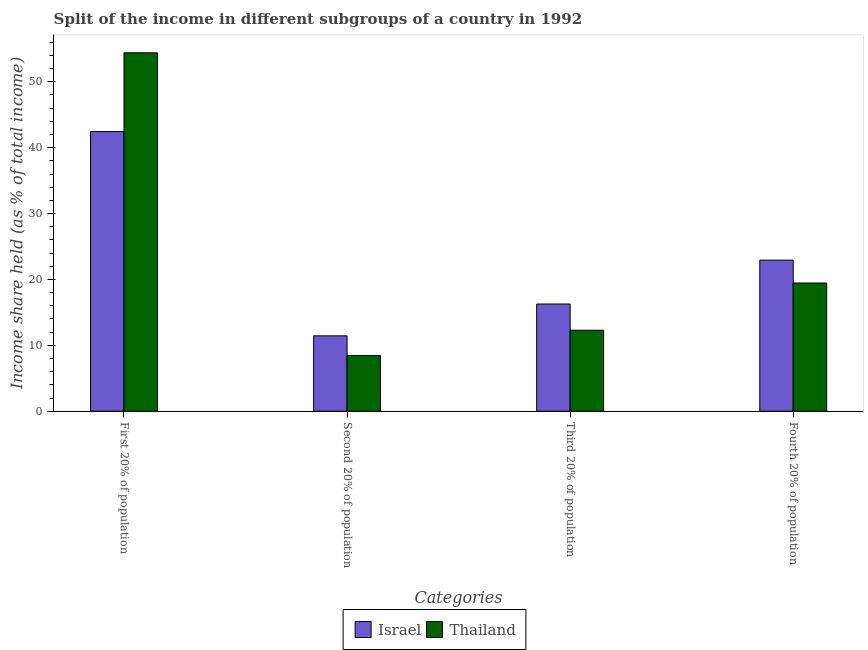How many different coloured bars are there?
Offer a terse response. 2. How many groups of bars are there?
Give a very brief answer. 4. Are the number of bars per tick equal to the number of legend labels?
Your answer should be very brief. Yes. How many bars are there on the 1st tick from the left?
Offer a very short reply. 2. How many bars are there on the 2nd tick from the right?
Your answer should be compact. 2. What is the label of the 3rd group of bars from the left?
Make the answer very short. Third 20% of population. What is the share of the income held by second 20% of the population in Thailand?
Offer a very short reply. 8.46. Across all countries, what is the maximum share of the income held by third 20% of the population?
Your answer should be very brief. 16.27. Across all countries, what is the minimum share of the income held by second 20% of the population?
Give a very brief answer. 8.46. In which country was the share of the income held by second 20% of the population maximum?
Make the answer very short. Israel. In which country was the share of the income held by third 20% of the population minimum?
Your answer should be compact. Thailand. What is the total share of the income held by third 20% of the population in the graph?
Provide a succinct answer. 28.56. What is the difference between the share of the income held by second 20% of the population in Israel and that in Thailand?
Make the answer very short. 2.98. What is the difference between the share of the income held by third 20% of the population in Thailand and the share of the income held by first 20% of the population in Israel?
Give a very brief answer. -30.15. What is the average share of the income held by second 20% of the population per country?
Ensure brevity in your answer.  9.95. What is the difference between the share of the income held by first 20% of the population and share of the income held by third 20% of the population in Thailand?
Keep it short and to the point. 42.11. In how many countries, is the share of the income held by fourth 20% of the population greater than 36 %?
Your answer should be very brief. 0. What is the ratio of the share of the income held by fourth 20% of the population in Thailand to that in Israel?
Provide a succinct answer. 0.85. What is the difference between the highest and the second highest share of the income held by second 20% of the population?
Offer a very short reply. 2.98. What is the difference between the highest and the lowest share of the income held by fourth 20% of the population?
Make the answer very short. 3.47. In how many countries, is the share of the income held by third 20% of the population greater than the average share of the income held by third 20% of the population taken over all countries?
Provide a short and direct response. 1. What does the 1st bar from the right in First 20% of population represents?
Ensure brevity in your answer.  Thailand. Is it the case that in every country, the sum of the share of the income held by first 20% of the population and share of the income held by second 20% of the population is greater than the share of the income held by third 20% of the population?
Make the answer very short. Yes. Are all the bars in the graph horizontal?
Provide a short and direct response. No. Are the values on the major ticks of Y-axis written in scientific E-notation?
Make the answer very short. No. Does the graph contain any zero values?
Offer a terse response. No. How many legend labels are there?
Keep it short and to the point. 2. How are the legend labels stacked?
Keep it short and to the point. Horizontal. What is the title of the graph?
Your response must be concise. Split of the income in different subgroups of a country in 1992. Does "Congo (Democratic)" appear as one of the legend labels in the graph?
Your response must be concise. No. What is the label or title of the X-axis?
Provide a short and direct response. Categories. What is the label or title of the Y-axis?
Provide a succinct answer. Income share held (as % of total income). What is the Income share held (as % of total income) in Israel in First 20% of population?
Your response must be concise. 42.44. What is the Income share held (as % of total income) in Thailand in First 20% of population?
Offer a terse response. 54.4. What is the Income share held (as % of total income) of Israel in Second 20% of population?
Ensure brevity in your answer.  11.44. What is the Income share held (as % of total income) of Thailand in Second 20% of population?
Your response must be concise. 8.46. What is the Income share held (as % of total income) in Israel in Third 20% of population?
Give a very brief answer. 16.27. What is the Income share held (as % of total income) in Thailand in Third 20% of population?
Offer a very short reply. 12.29. What is the Income share held (as % of total income) in Israel in Fourth 20% of population?
Give a very brief answer. 22.93. What is the Income share held (as % of total income) in Thailand in Fourth 20% of population?
Provide a succinct answer. 19.46. Across all Categories, what is the maximum Income share held (as % of total income) of Israel?
Your answer should be compact. 42.44. Across all Categories, what is the maximum Income share held (as % of total income) of Thailand?
Make the answer very short. 54.4. Across all Categories, what is the minimum Income share held (as % of total income) in Israel?
Provide a short and direct response. 11.44. Across all Categories, what is the minimum Income share held (as % of total income) of Thailand?
Your answer should be compact. 8.46. What is the total Income share held (as % of total income) of Israel in the graph?
Your answer should be compact. 93.08. What is the total Income share held (as % of total income) of Thailand in the graph?
Provide a short and direct response. 94.61. What is the difference between the Income share held (as % of total income) of Israel in First 20% of population and that in Second 20% of population?
Provide a short and direct response. 31. What is the difference between the Income share held (as % of total income) of Thailand in First 20% of population and that in Second 20% of population?
Offer a very short reply. 45.94. What is the difference between the Income share held (as % of total income) in Israel in First 20% of population and that in Third 20% of population?
Your answer should be very brief. 26.17. What is the difference between the Income share held (as % of total income) in Thailand in First 20% of population and that in Third 20% of population?
Your answer should be compact. 42.11. What is the difference between the Income share held (as % of total income) of Israel in First 20% of population and that in Fourth 20% of population?
Make the answer very short. 19.51. What is the difference between the Income share held (as % of total income) of Thailand in First 20% of population and that in Fourth 20% of population?
Make the answer very short. 34.94. What is the difference between the Income share held (as % of total income) in Israel in Second 20% of population and that in Third 20% of population?
Your response must be concise. -4.83. What is the difference between the Income share held (as % of total income) of Thailand in Second 20% of population and that in Third 20% of population?
Your answer should be very brief. -3.83. What is the difference between the Income share held (as % of total income) in Israel in Second 20% of population and that in Fourth 20% of population?
Your answer should be very brief. -11.49. What is the difference between the Income share held (as % of total income) in Israel in Third 20% of population and that in Fourth 20% of population?
Make the answer very short. -6.66. What is the difference between the Income share held (as % of total income) of Thailand in Third 20% of population and that in Fourth 20% of population?
Offer a terse response. -7.17. What is the difference between the Income share held (as % of total income) of Israel in First 20% of population and the Income share held (as % of total income) of Thailand in Second 20% of population?
Provide a short and direct response. 33.98. What is the difference between the Income share held (as % of total income) in Israel in First 20% of population and the Income share held (as % of total income) in Thailand in Third 20% of population?
Provide a succinct answer. 30.15. What is the difference between the Income share held (as % of total income) of Israel in First 20% of population and the Income share held (as % of total income) of Thailand in Fourth 20% of population?
Your response must be concise. 22.98. What is the difference between the Income share held (as % of total income) of Israel in Second 20% of population and the Income share held (as % of total income) of Thailand in Third 20% of population?
Keep it short and to the point. -0.85. What is the difference between the Income share held (as % of total income) of Israel in Second 20% of population and the Income share held (as % of total income) of Thailand in Fourth 20% of population?
Provide a succinct answer. -8.02. What is the difference between the Income share held (as % of total income) of Israel in Third 20% of population and the Income share held (as % of total income) of Thailand in Fourth 20% of population?
Provide a succinct answer. -3.19. What is the average Income share held (as % of total income) of Israel per Categories?
Keep it short and to the point. 23.27. What is the average Income share held (as % of total income) of Thailand per Categories?
Your response must be concise. 23.65. What is the difference between the Income share held (as % of total income) of Israel and Income share held (as % of total income) of Thailand in First 20% of population?
Provide a short and direct response. -11.96. What is the difference between the Income share held (as % of total income) in Israel and Income share held (as % of total income) in Thailand in Second 20% of population?
Give a very brief answer. 2.98. What is the difference between the Income share held (as % of total income) in Israel and Income share held (as % of total income) in Thailand in Third 20% of population?
Provide a short and direct response. 3.98. What is the difference between the Income share held (as % of total income) of Israel and Income share held (as % of total income) of Thailand in Fourth 20% of population?
Keep it short and to the point. 3.47. What is the ratio of the Income share held (as % of total income) of Israel in First 20% of population to that in Second 20% of population?
Offer a very short reply. 3.71. What is the ratio of the Income share held (as % of total income) of Thailand in First 20% of population to that in Second 20% of population?
Your answer should be very brief. 6.43. What is the ratio of the Income share held (as % of total income) in Israel in First 20% of population to that in Third 20% of population?
Offer a very short reply. 2.61. What is the ratio of the Income share held (as % of total income) of Thailand in First 20% of population to that in Third 20% of population?
Keep it short and to the point. 4.43. What is the ratio of the Income share held (as % of total income) of Israel in First 20% of population to that in Fourth 20% of population?
Make the answer very short. 1.85. What is the ratio of the Income share held (as % of total income) of Thailand in First 20% of population to that in Fourth 20% of population?
Your answer should be compact. 2.8. What is the ratio of the Income share held (as % of total income) of Israel in Second 20% of population to that in Third 20% of population?
Provide a short and direct response. 0.7. What is the ratio of the Income share held (as % of total income) in Thailand in Second 20% of population to that in Third 20% of population?
Your answer should be compact. 0.69. What is the ratio of the Income share held (as % of total income) in Israel in Second 20% of population to that in Fourth 20% of population?
Keep it short and to the point. 0.5. What is the ratio of the Income share held (as % of total income) of Thailand in Second 20% of population to that in Fourth 20% of population?
Keep it short and to the point. 0.43. What is the ratio of the Income share held (as % of total income) of Israel in Third 20% of population to that in Fourth 20% of population?
Your response must be concise. 0.71. What is the ratio of the Income share held (as % of total income) of Thailand in Third 20% of population to that in Fourth 20% of population?
Ensure brevity in your answer.  0.63. What is the difference between the highest and the second highest Income share held (as % of total income) of Israel?
Provide a short and direct response. 19.51. What is the difference between the highest and the second highest Income share held (as % of total income) in Thailand?
Ensure brevity in your answer.  34.94. What is the difference between the highest and the lowest Income share held (as % of total income) of Israel?
Your answer should be very brief. 31. What is the difference between the highest and the lowest Income share held (as % of total income) in Thailand?
Give a very brief answer. 45.94. 